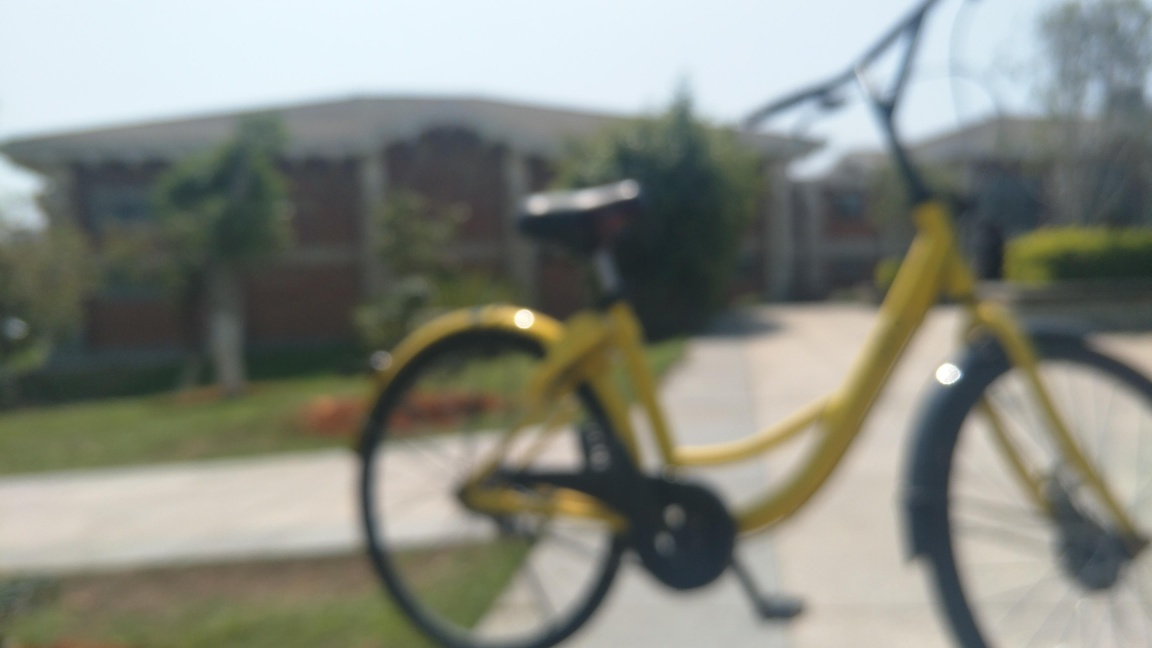What time of day does this photo seem to have been taken? Judging by the bright and warm quality of the light, along with the lack of long shadows, it seems like the photo was taken around midday. 